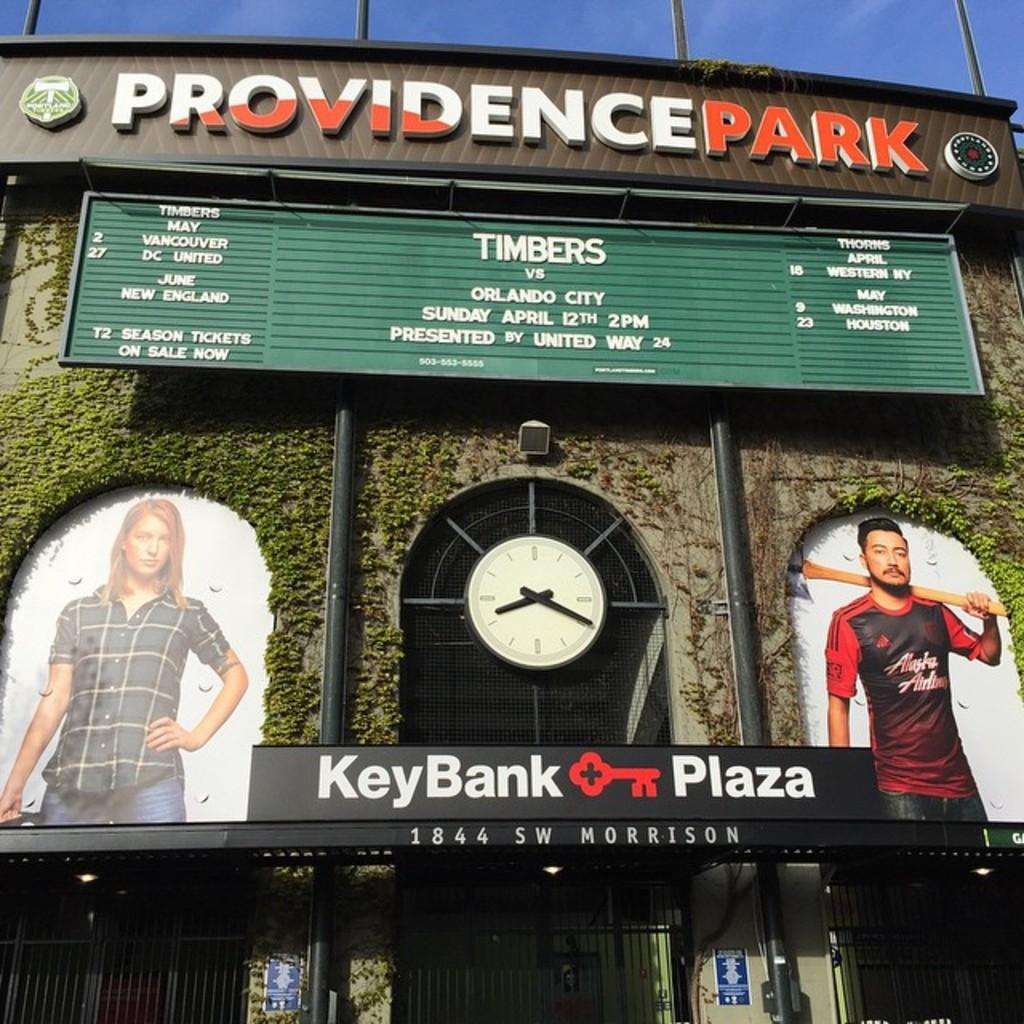<image>
Create a compact narrative representing the image presented. A sign at Providence park for the Timbers vs Orlando city. 